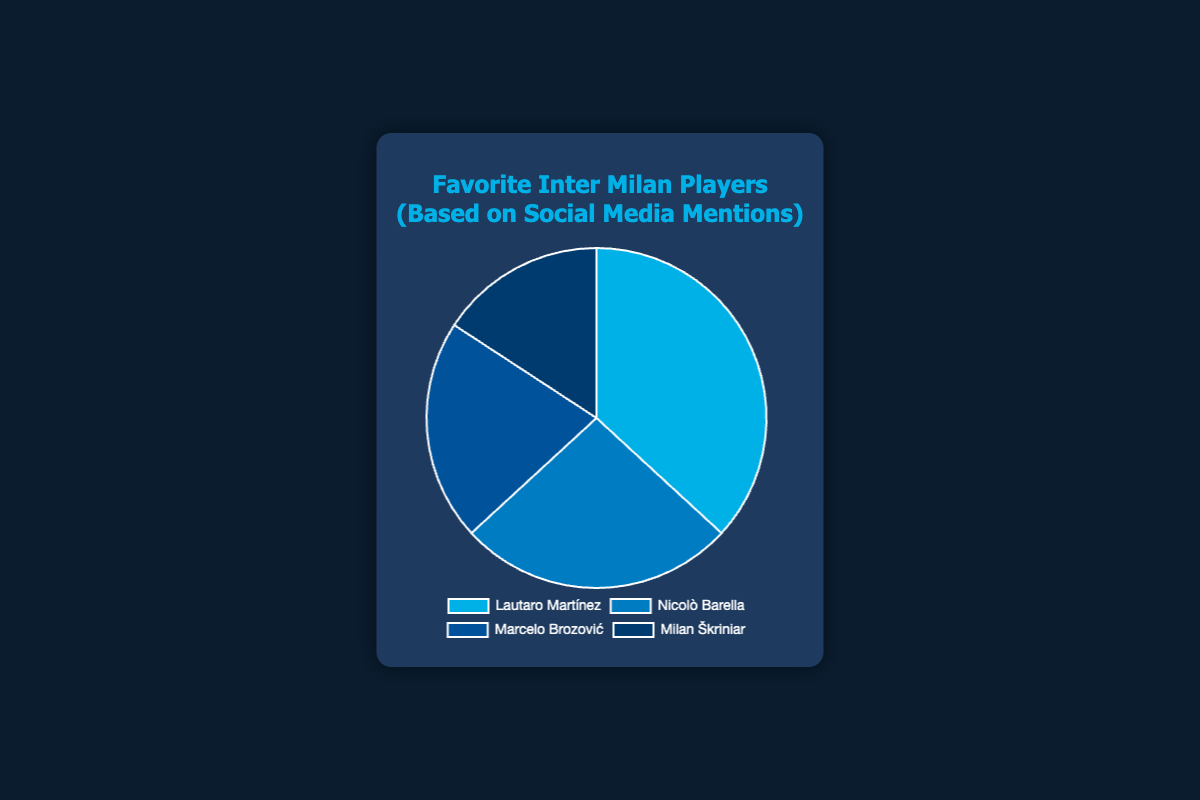Which Inter Milan player has the most social media mentions? Lautaro Martínez has the highest number of social media mentions with 35,000. This information can be determined by looking at the data points and identifying the player with the highest value.
Answer: Lautaro Martínez Which player has fewer mentions than Marcelo Brozović but more than Milan Škriniar? Nicolò Barella has 25,000 mentions, which is fewer than Marcelo Brozović's 20,000 but more than Milan Škriniar's 15,000. By comparing the mentions, you can see that Nicolò Barella fits this criterion.
Answer: Nicolò Barella What is the total number of social media mentions for all four players combined? The sum of all social media mentions is calculated by adding the mentions for each player: 35,000 (Lautaro Martínez) + 25,000 (Nicolò Barella) + 20,000 (Marcelo Brozović) + 15,000 (Milan Škriniar) = 95,000.
Answer: 95,000 By how many mentions does Lautaro Martínez exceed Milan Škriniar? The difference is found by subtracting Milan Škriniar's mentions from Lautaro Martínez's mentions: 35,000 - 15,000 = 20,000. Lautaro Martínez exceeds Milan Škriniar by 20,000 mentions.
Answer: 20,000 What is the average number of social media mentions per player? The average is calculated by dividing the total mentions by the number of players. With 95,000 total mentions and 4 players, the average is 95,000 / 4 = 23,750 mentions per player.
Answer: 23,750 Which player has the least social media mentions? Milan Škriniar has the least number of social media mentions with 15,000. This is determined by identifying the smallest value among the given data points.
Answer: Milan Škriniar How many more mentions does Lautaro Martínez have compared to Nicolò Barella? Lautaro Martínez has 10,000 more mentions compared to Nicolò Barella, as the difference is calculated by subtracting 25,000 from 35,000.
Answer: 10,000 Which players have social media mentions that sum up to 45,000? The pairs of players whose mentions sum up to 45,000 are Nicolò Barella (25,000) and Marcelo Brozović (20,000). Adding their mentions gives 25,000 + 20,000 = 45,000.
Answer: Nicolò Barella and Marcelo Brozović 